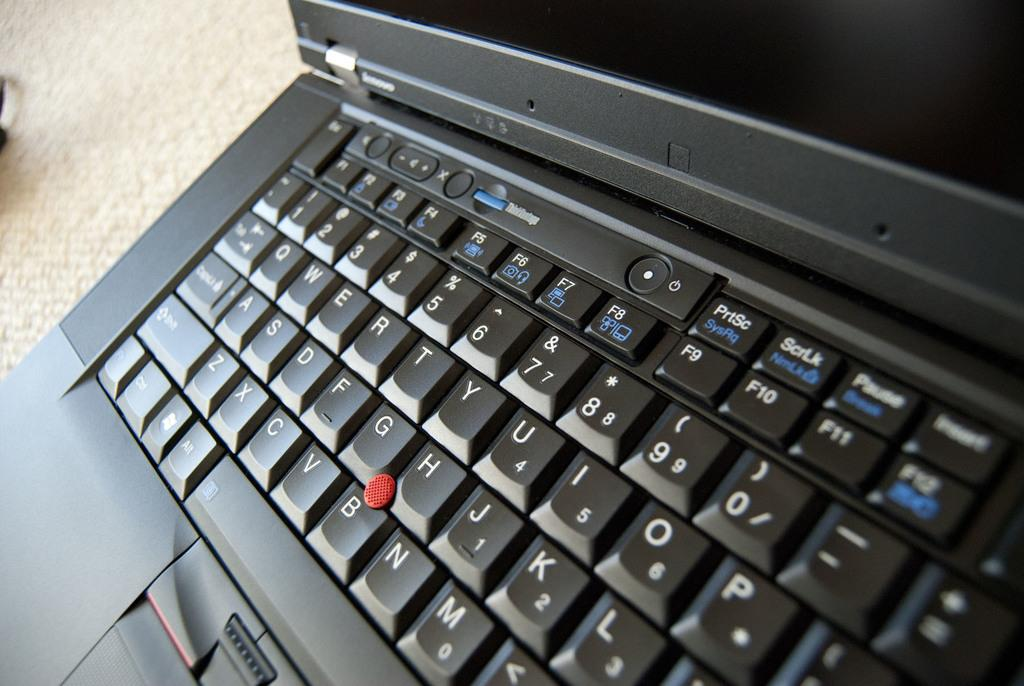<image>
Relay a brief, clear account of the picture shown. Black laptop with a F5 button next to the F6 button. 